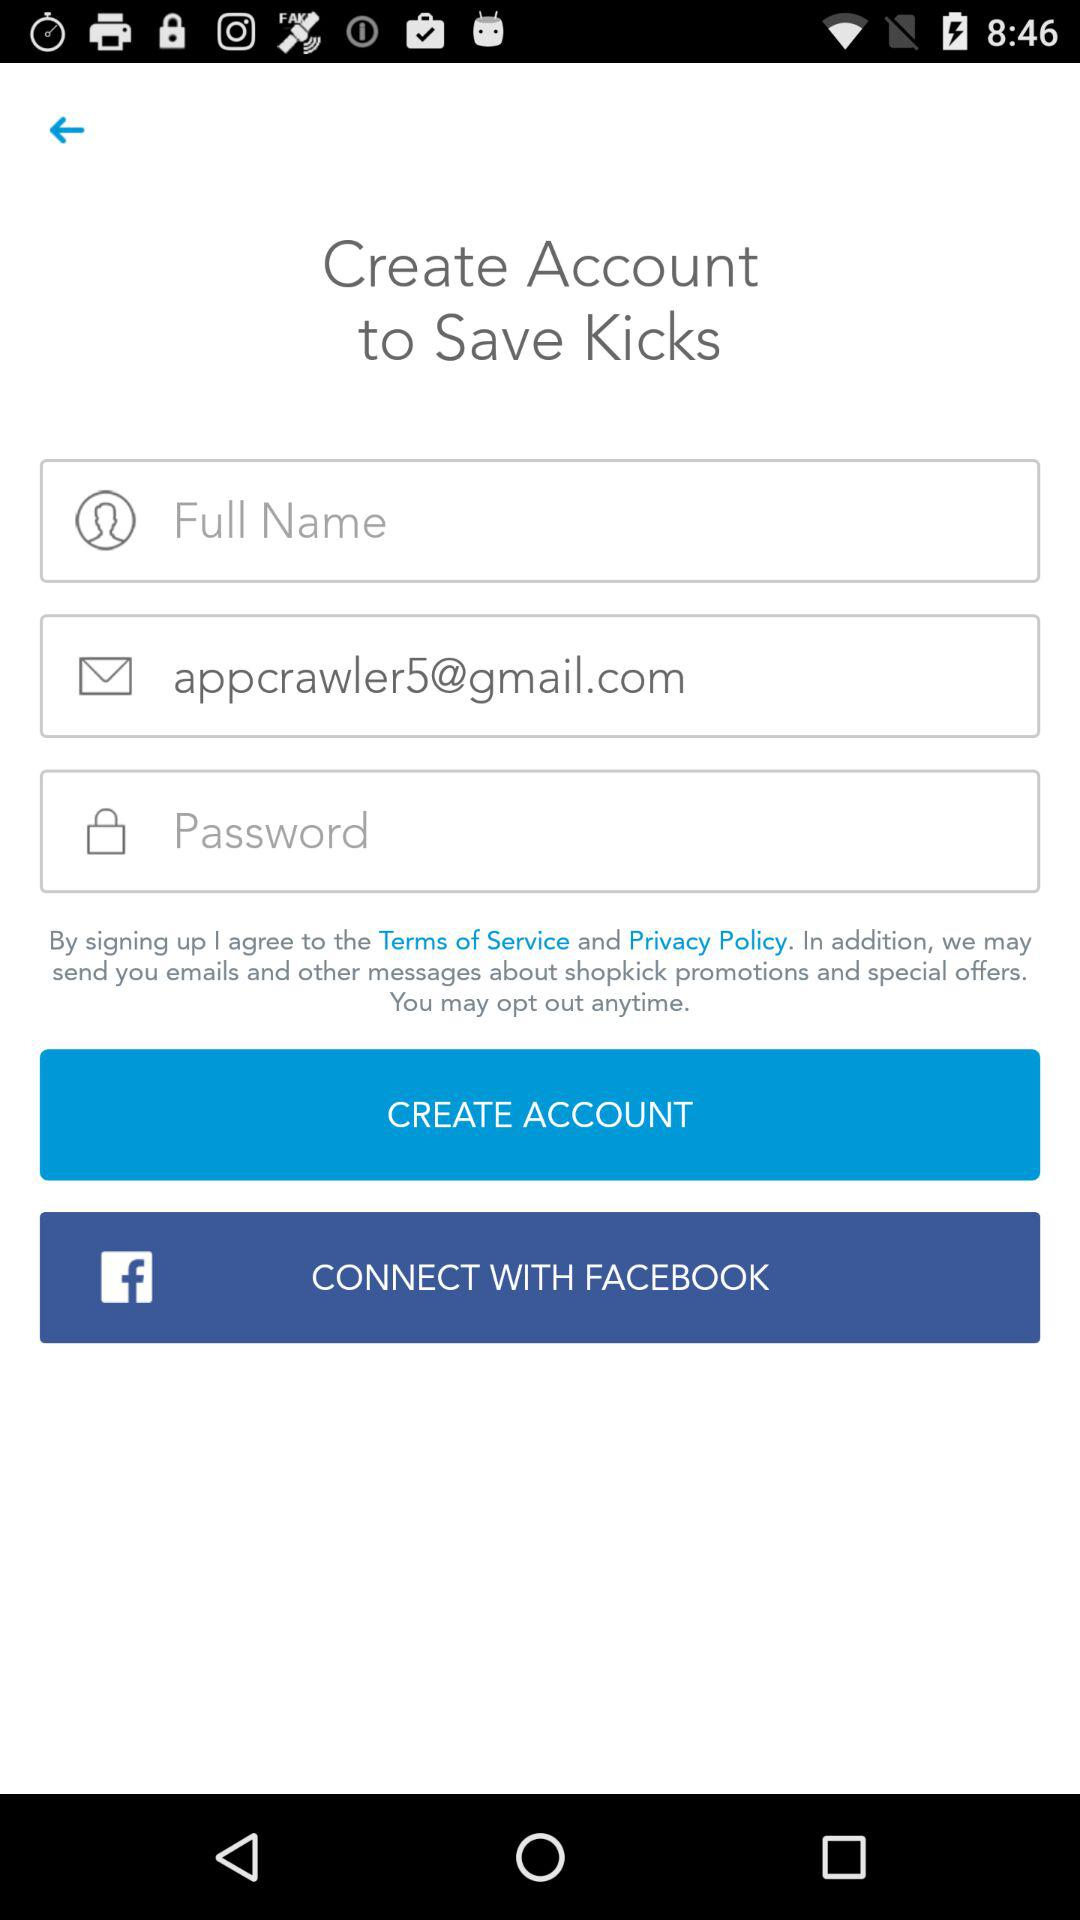What application can be used to connect? The application "FACEBOOK" can be used to connect. 